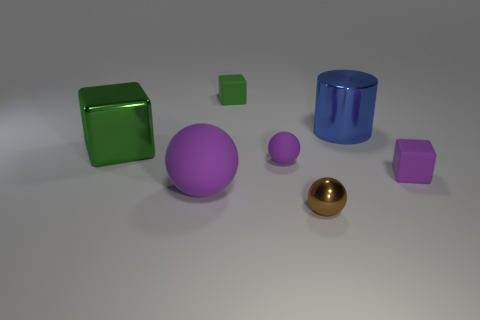Is there anything else that has the same shape as the blue object?
Make the answer very short. No. Are there an equal number of small rubber things that are left of the tiny brown metallic sphere and gray matte blocks?
Your answer should be very brief. No. Do the large ball and the rubber sphere behind the big purple rubber ball have the same color?
Provide a succinct answer. Yes. What is the color of the block that is both in front of the blue cylinder and on the right side of the big ball?
Make the answer very short. Purple. There is a purple rubber object that is in front of the purple matte cube; what number of green rubber blocks are in front of it?
Offer a very short reply. 0. Are there any other things of the same shape as the large green object?
Offer a very short reply. Yes. Do the tiny object that is behind the big block and the big green metal thing behind the small brown metallic ball have the same shape?
Your answer should be compact. Yes. How many objects are large purple matte things or purple matte spheres?
Your answer should be very brief. 2. What is the size of the other green metallic thing that is the same shape as the small green object?
Your answer should be very brief. Large. Is the number of green shiny cubes in front of the large green shiny block greater than the number of green rubber things?
Give a very brief answer. No. 